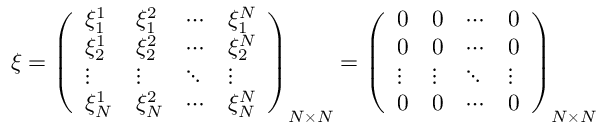Convert formula to latex. <formula><loc_0><loc_0><loc_500><loc_500>\xi = \left ( \begin{array} { l l l l } { \xi _ { 1 } ^ { 1 } } & { \xi _ { 1 } ^ { 2 } } & { \cdots } & { \xi _ { 1 } ^ { N } } \\ { \xi _ { 2 } ^ { 1 } } & { \xi _ { 2 } ^ { 2 } } & { \cdots } & { \xi _ { 2 } ^ { N } } \\ { \vdots } & { \vdots } & { \ddots } & { \vdots } \\ { \xi _ { N } ^ { 1 } } & { \xi _ { N } ^ { 2 } } & { \cdots } & { \xi _ { N } ^ { N } } \end{array} \right ) _ { N \times N } = \left ( \begin{array} { l l l l } { 0 } & { 0 } & { \cdots } & { 0 } \\ { 0 } & { 0 } & { \cdots } & { 0 } \\ { \vdots } & { \vdots } & { \ddots } & { \vdots } \\ { 0 } & { 0 } & { \cdots } & { 0 } \end{array} \right ) _ { N \times N }</formula> 